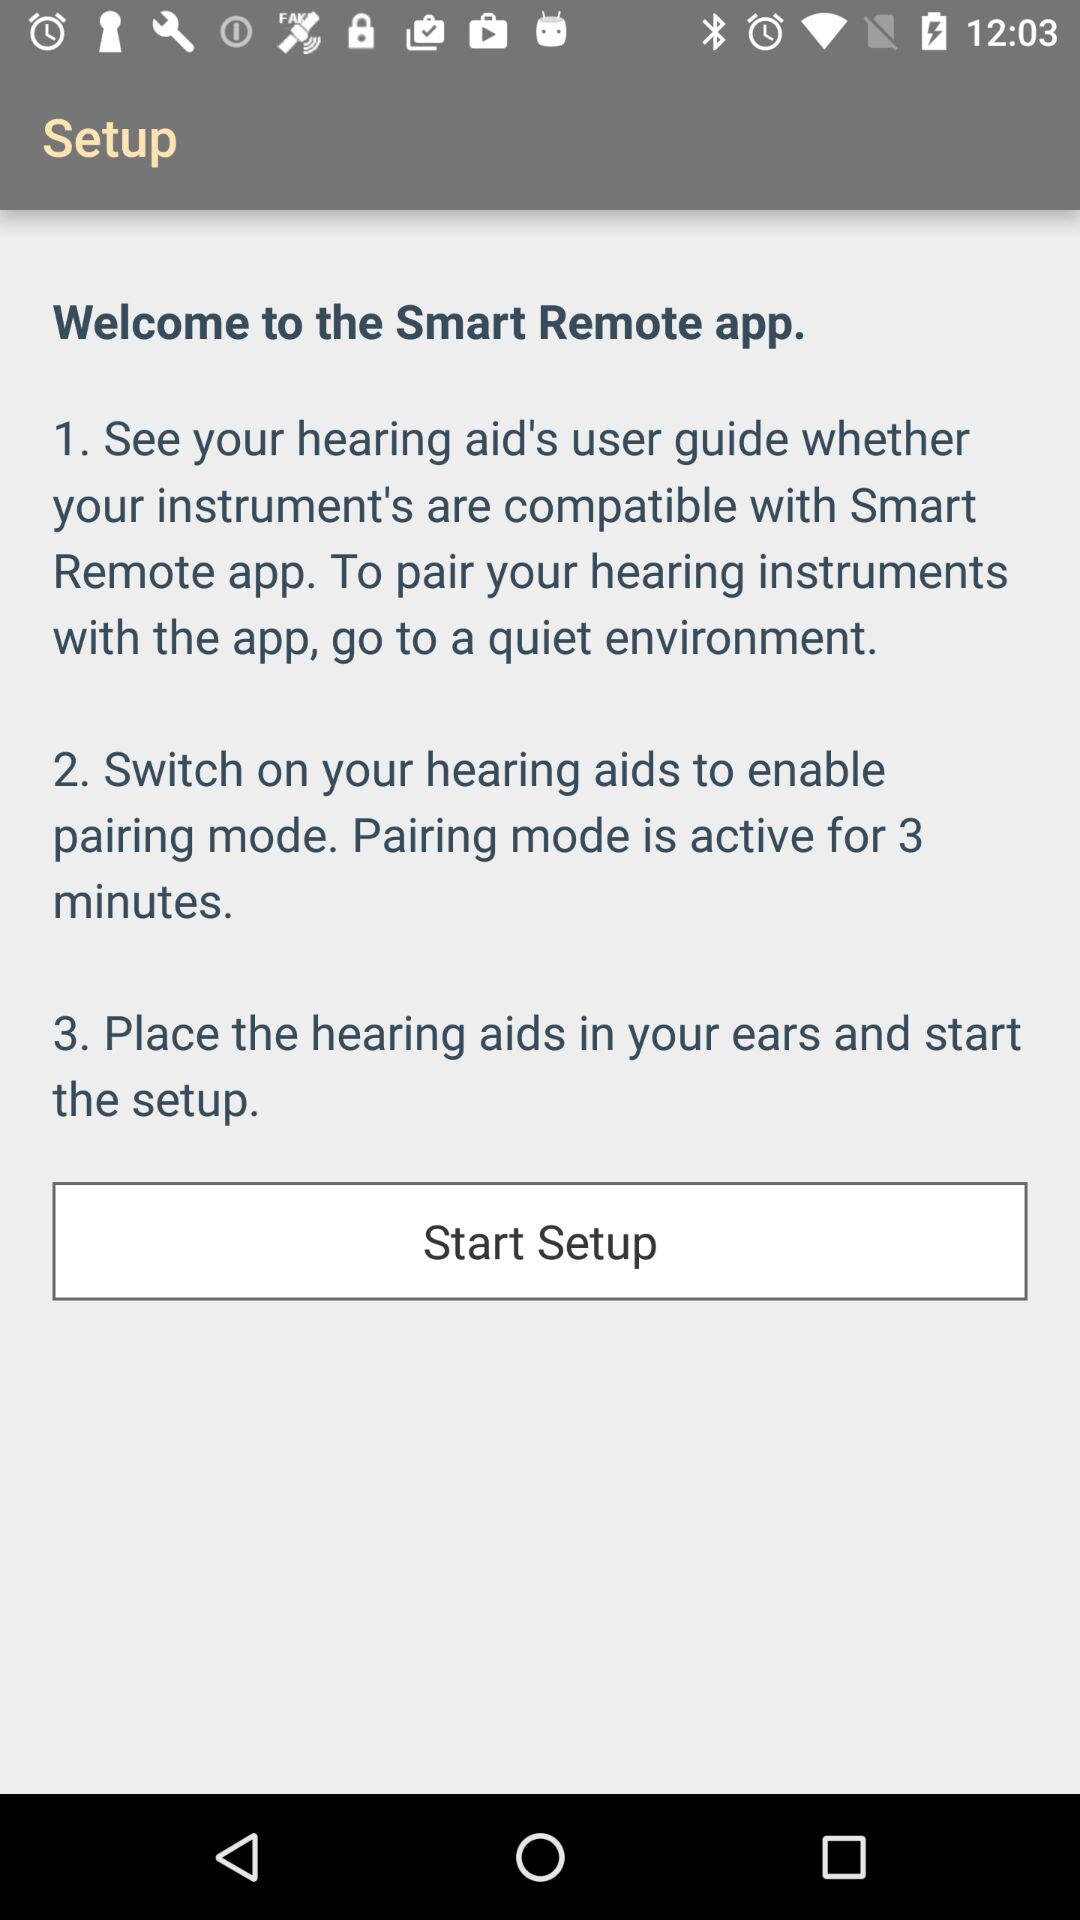How long is the pairing mode active for?
Answer the question using a single word or phrase. 3 minutes 